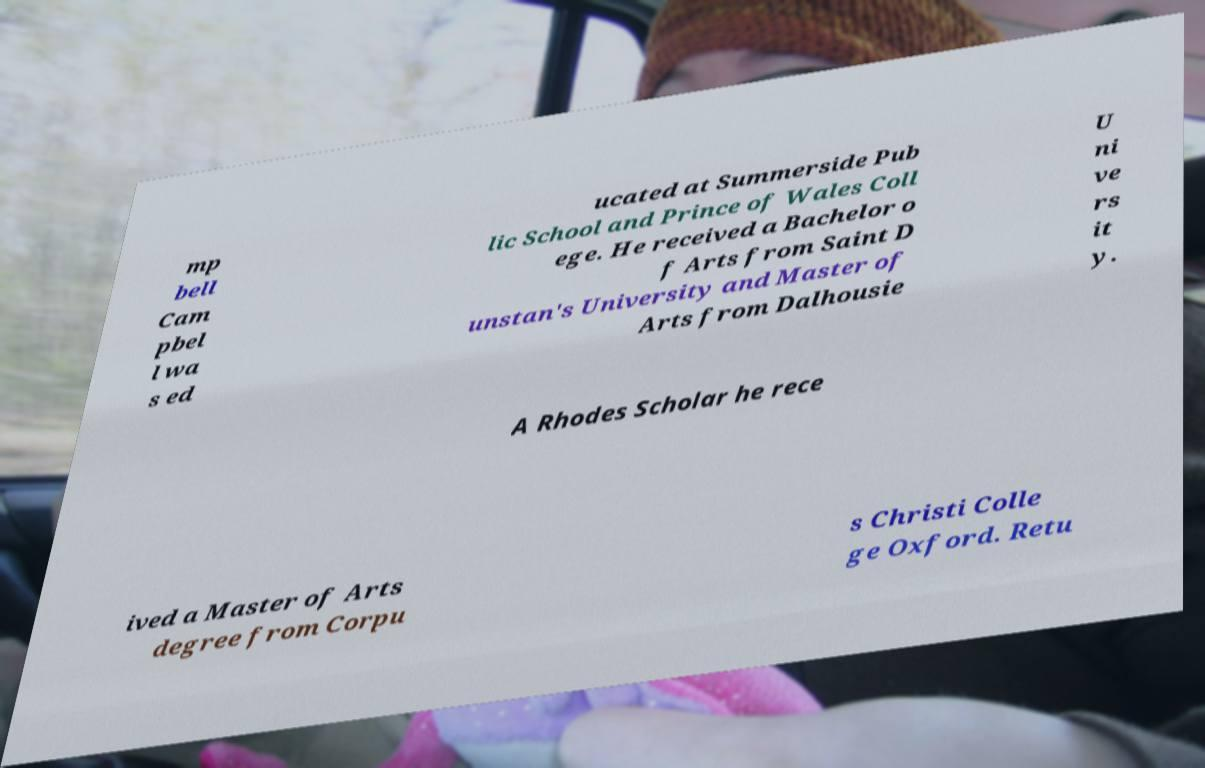Please read and relay the text visible in this image. What does it say? mp bell Cam pbel l wa s ed ucated at Summerside Pub lic School and Prince of Wales Coll ege. He received a Bachelor o f Arts from Saint D unstan's University and Master of Arts from Dalhousie U ni ve rs it y. A Rhodes Scholar he rece ived a Master of Arts degree from Corpu s Christi Colle ge Oxford. Retu 